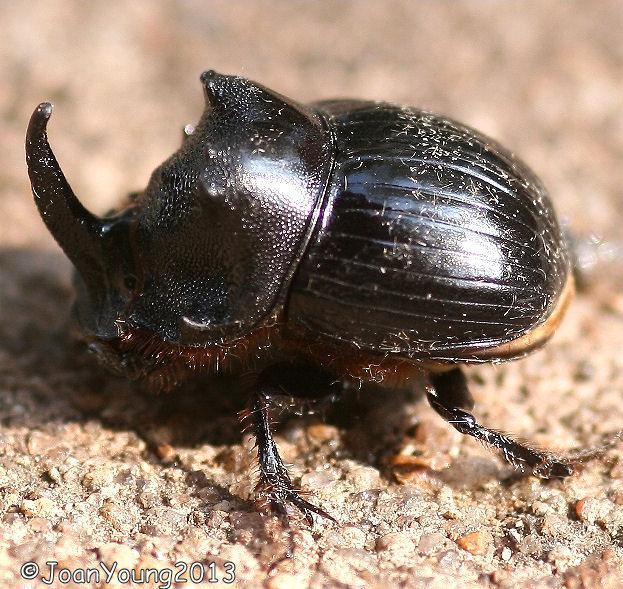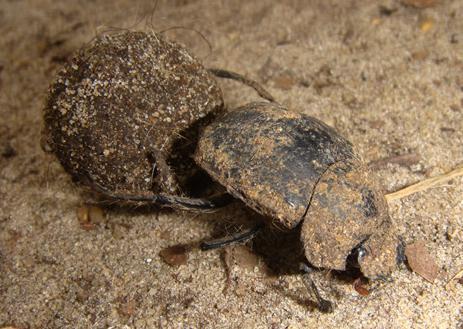The first image is the image on the left, the second image is the image on the right. For the images displayed, is the sentence "The right image has two beetles pushing a dung ball." factually correct? Answer yes or no. No. The first image is the image on the left, the second image is the image on the right. Considering the images on both sides, is "In each image, there are two beetles holding a dungball.›" valid? Answer yes or no. No. 